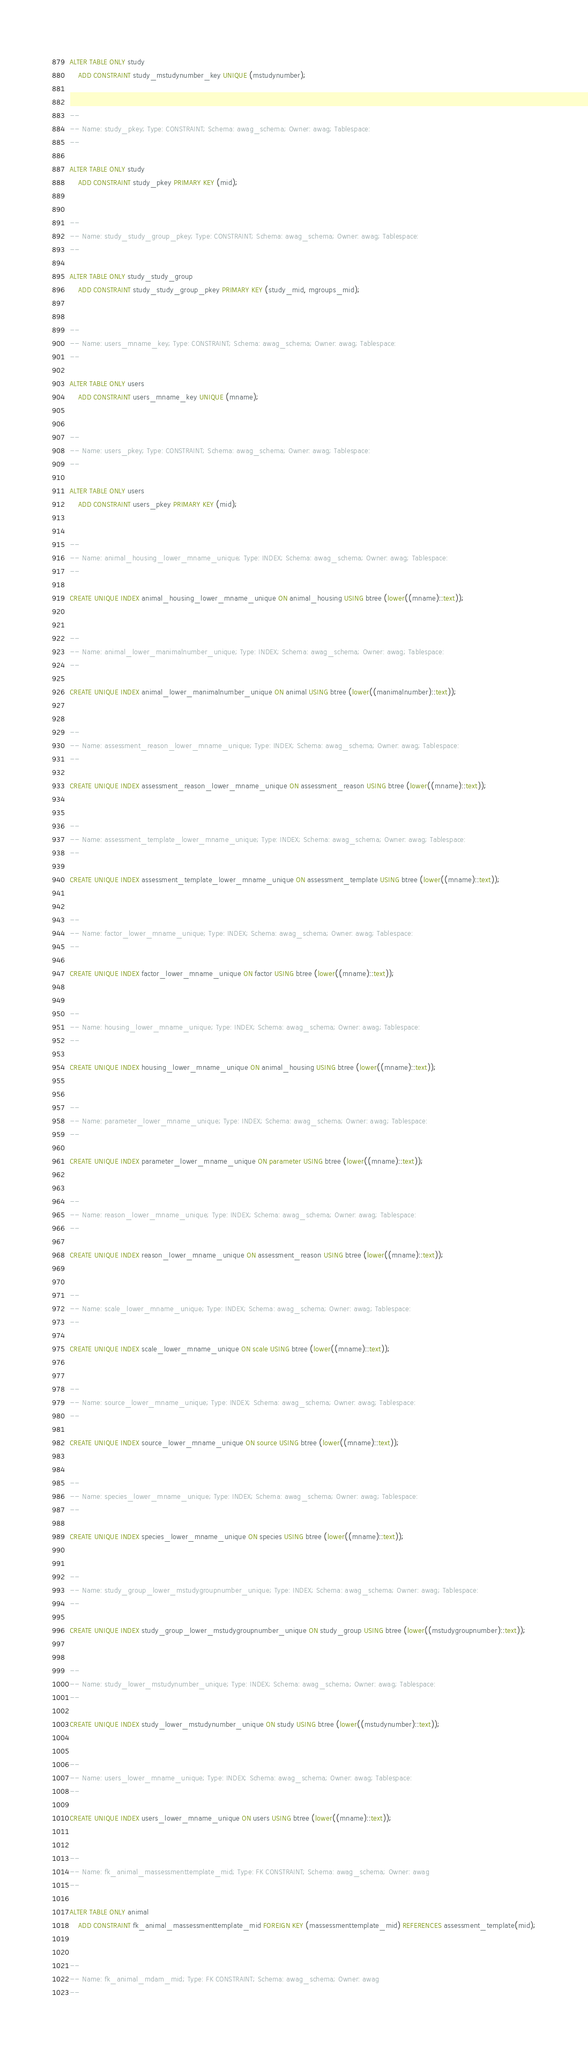<code> <loc_0><loc_0><loc_500><loc_500><_SQL_>ALTER TABLE ONLY study
    ADD CONSTRAINT study_mstudynumber_key UNIQUE (mstudynumber);


--
-- Name: study_pkey; Type: CONSTRAINT; Schema: awag_schema; Owner: awag; Tablespace: 
--

ALTER TABLE ONLY study
    ADD CONSTRAINT study_pkey PRIMARY KEY (mid);


--
-- Name: study_study_group_pkey; Type: CONSTRAINT; Schema: awag_schema; Owner: awag; Tablespace: 
--

ALTER TABLE ONLY study_study_group
    ADD CONSTRAINT study_study_group_pkey PRIMARY KEY (study_mid, mgroups_mid);


--
-- Name: users_mname_key; Type: CONSTRAINT; Schema: awag_schema; Owner: awag; Tablespace: 
--

ALTER TABLE ONLY users
    ADD CONSTRAINT users_mname_key UNIQUE (mname);


--
-- Name: users_pkey; Type: CONSTRAINT; Schema: awag_schema; Owner: awag; Tablespace: 
--

ALTER TABLE ONLY users
    ADD CONSTRAINT users_pkey PRIMARY KEY (mid);


--
-- Name: animal_housing_lower_mname_unique; Type: INDEX; Schema: awag_schema; Owner: awag; Tablespace: 
--

CREATE UNIQUE INDEX animal_housing_lower_mname_unique ON animal_housing USING btree (lower((mname)::text));


--
-- Name: animal_lower_manimalnumber_unique; Type: INDEX; Schema: awag_schema; Owner: awag; Tablespace: 
--

CREATE UNIQUE INDEX animal_lower_manimalnumber_unique ON animal USING btree (lower((manimalnumber)::text));


--
-- Name: assessment_reason_lower_mname_unique; Type: INDEX; Schema: awag_schema; Owner: awag; Tablespace: 
--

CREATE UNIQUE INDEX assessment_reason_lower_mname_unique ON assessment_reason USING btree (lower((mname)::text));


--
-- Name: assessment_template_lower_mname_unique; Type: INDEX; Schema: awag_schema; Owner: awag; Tablespace: 
--

CREATE UNIQUE INDEX assessment_template_lower_mname_unique ON assessment_template USING btree (lower((mname)::text));


--
-- Name: factor_lower_mname_unique; Type: INDEX; Schema: awag_schema; Owner: awag; Tablespace: 
--

CREATE UNIQUE INDEX factor_lower_mname_unique ON factor USING btree (lower((mname)::text));


--
-- Name: housing_lower_mname_unique; Type: INDEX; Schema: awag_schema; Owner: awag; Tablespace: 
--

CREATE UNIQUE INDEX housing_lower_mname_unique ON animal_housing USING btree (lower((mname)::text));


--
-- Name: parameter_lower_mname_unique; Type: INDEX; Schema: awag_schema; Owner: awag; Tablespace: 
--

CREATE UNIQUE INDEX parameter_lower_mname_unique ON parameter USING btree (lower((mname)::text));


--
-- Name: reason_lower_mname_unique; Type: INDEX; Schema: awag_schema; Owner: awag; Tablespace: 
--

CREATE UNIQUE INDEX reason_lower_mname_unique ON assessment_reason USING btree (lower((mname)::text));


--
-- Name: scale_lower_mname_unique; Type: INDEX; Schema: awag_schema; Owner: awag; Tablespace: 
--

CREATE UNIQUE INDEX scale_lower_mname_unique ON scale USING btree (lower((mname)::text));


--
-- Name: source_lower_mname_unique; Type: INDEX; Schema: awag_schema; Owner: awag; Tablespace: 
--

CREATE UNIQUE INDEX source_lower_mname_unique ON source USING btree (lower((mname)::text));


--
-- Name: species_lower_mname_unique; Type: INDEX; Schema: awag_schema; Owner: awag; Tablespace: 
--

CREATE UNIQUE INDEX species_lower_mname_unique ON species USING btree (lower((mname)::text));


--
-- Name: study_group_lower_mstudygroupnumber_unique; Type: INDEX; Schema: awag_schema; Owner: awag; Tablespace: 
--

CREATE UNIQUE INDEX study_group_lower_mstudygroupnumber_unique ON study_group USING btree (lower((mstudygroupnumber)::text));


--
-- Name: study_lower_mstudynumber_unique; Type: INDEX; Schema: awag_schema; Owner: awag; Tablespace: 
--

CREATE UNIQUE INDEX study_lower_mstudynumber_unique ON study USING btree (lower((mstudynumber)::text));


--
-- Name: users_lower_mname_unique; Type: INDEX; Schema: awag_schema; Owner: awag; Tablespace: 
--

CREATE UNIQUE INDEX users_lower_mname_unique ON users USING btree (lower((mname)::text));


--
-- Name: fk_animal_massessmenttemplate_mid; Type: FK CONSTRAINT; Schema: awag_schema; Owner: awag
--

ALTER TABLE ONLY animal
    ADD CONSTRAINT fk_animal_massessmenttemplate_mid FOREIGN KEY (massessmenttemplate_mid) REFERENCES assessment_template(mid);


--
-- Name: fk_animal_mdam_mid; Type: FK CONSTRAINT; Schema: awag_schema; Owner: awag
--
</code> 